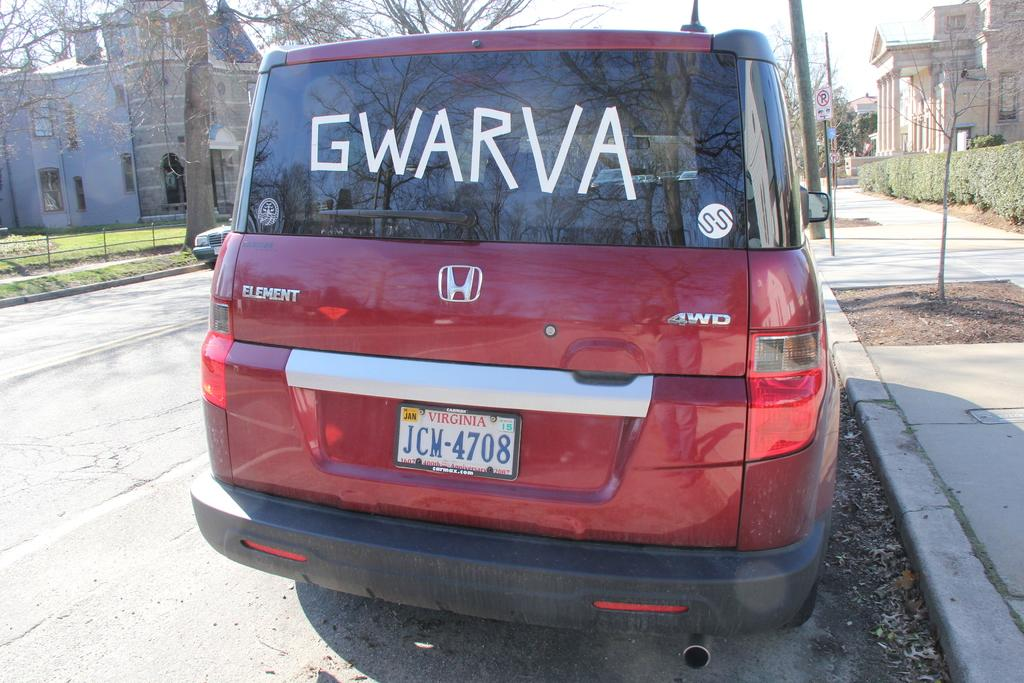What is the main subject of the image? There is a car on the road in the image. What can be seen in the background of the image? There are buildings, trees, an iron pole, and the sky visible in the background of the image. How many mittens are hanging on the iron pole in the image? There are no mittens present in the image; only an iron pole is visible in the background. What type of balls can be seen bouncing on the road in the image? There are no balls present in the image; the main subject is a car on the road. 